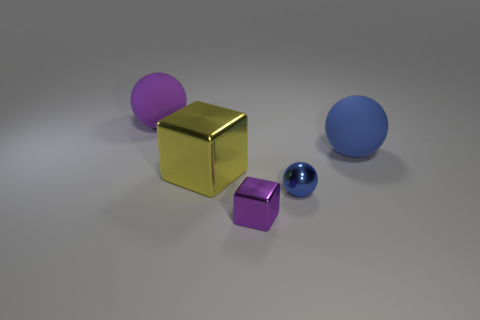What is the shape of the thing that is the same color as the small ball?
Your answer should be compact. Sphere. What number of purple matte things have the same size as the yellow object?
Ensure brevity in your answer.  1. What number of big blue rubber spheres are on the left side of the purple ball?
Ensure brevity in your answer.  0. What material is the tiny thing that is behind the purple object that is in front of the blue rubber sphere?
Provide a short and direct response. Metal. Are there any small spheres of the same color as the big metallic thing?
Offer a terse response. No. The blue object that is made of the same material as the big cube is what size?
Provide a short and direct response. Small. Is there any other thing that has the same color as the big metal object?
Ensure brevity in your answer.  No. There is a metal block on the left side of the small purple thing; what color is it?
Your answer should be compact. Yellow. Are there any big yellow things on the left side of the big matte ball that is on the left side of the small blue sphere that is right of the tiny purple shiny block?
Ensure brevity in your answer.  No. Is the number of small objects that are behind the blue metallic sphere greater than the number of purple matte objects?
Keep it short and to the point. No. 